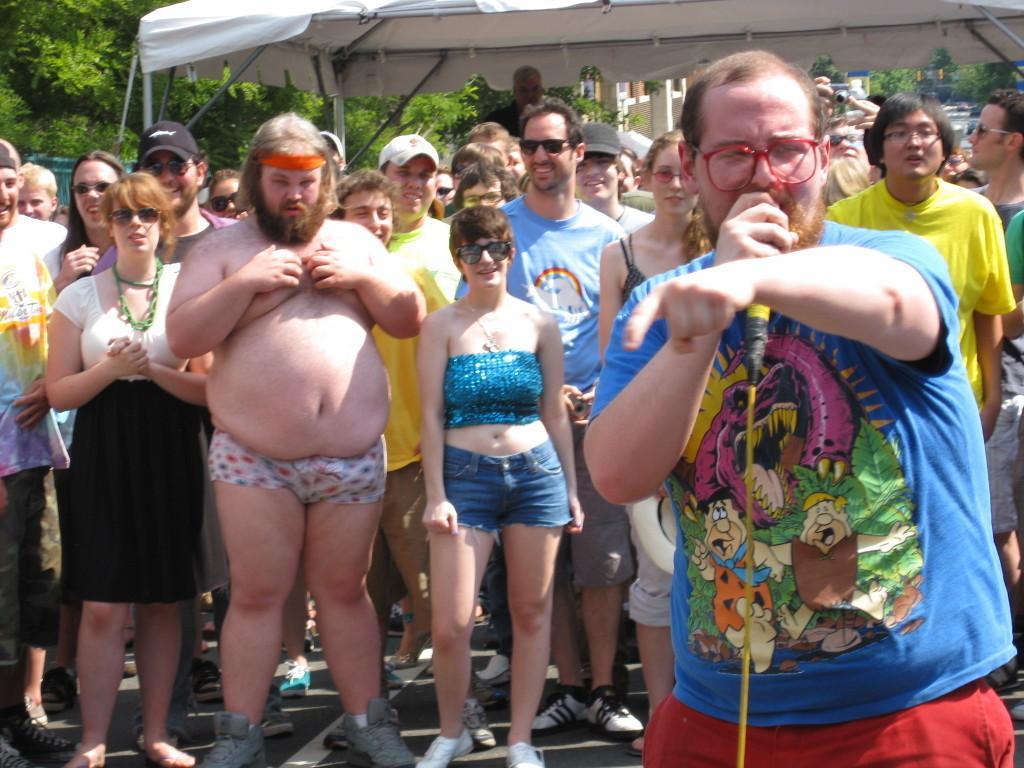Describe this image in one or two sentences. In this image we can see group of people standing. One person wearing blue t shirt and red shorts is holding microphone in his hand. In the background we can see a shed group of trees and building. 